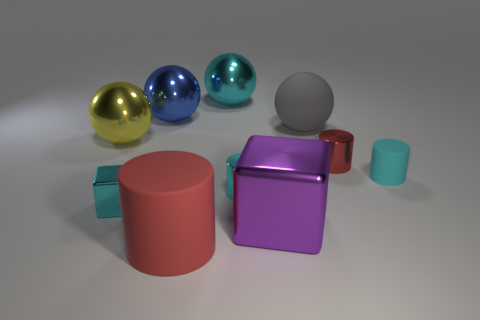Subtract all large gray matte balls. How many balls are left? 3 Subtract all cyan cylinders. How many cylinders are left? 2 Subtract all balls. How many objects are left? 6 Subtract 3 cylinders. How many cylinders are left? 1 Subtract 0 brown cubes. How many objects are left? 10 Subtract all green balls. Subtract all red cylinders. How many balls are left? 4 Subtract all green cylinders. How many yellow balls are left? 1 Subtract all tiny matte blocks. Subtract all matte objects. How many objects are left? 7 Add 8 tiny cyan rubber cylinders. How many tiny cyan rubber cylinders are left? 9 Add 5 big yellow metallic things. How many big yellow metallic things exist? 6 